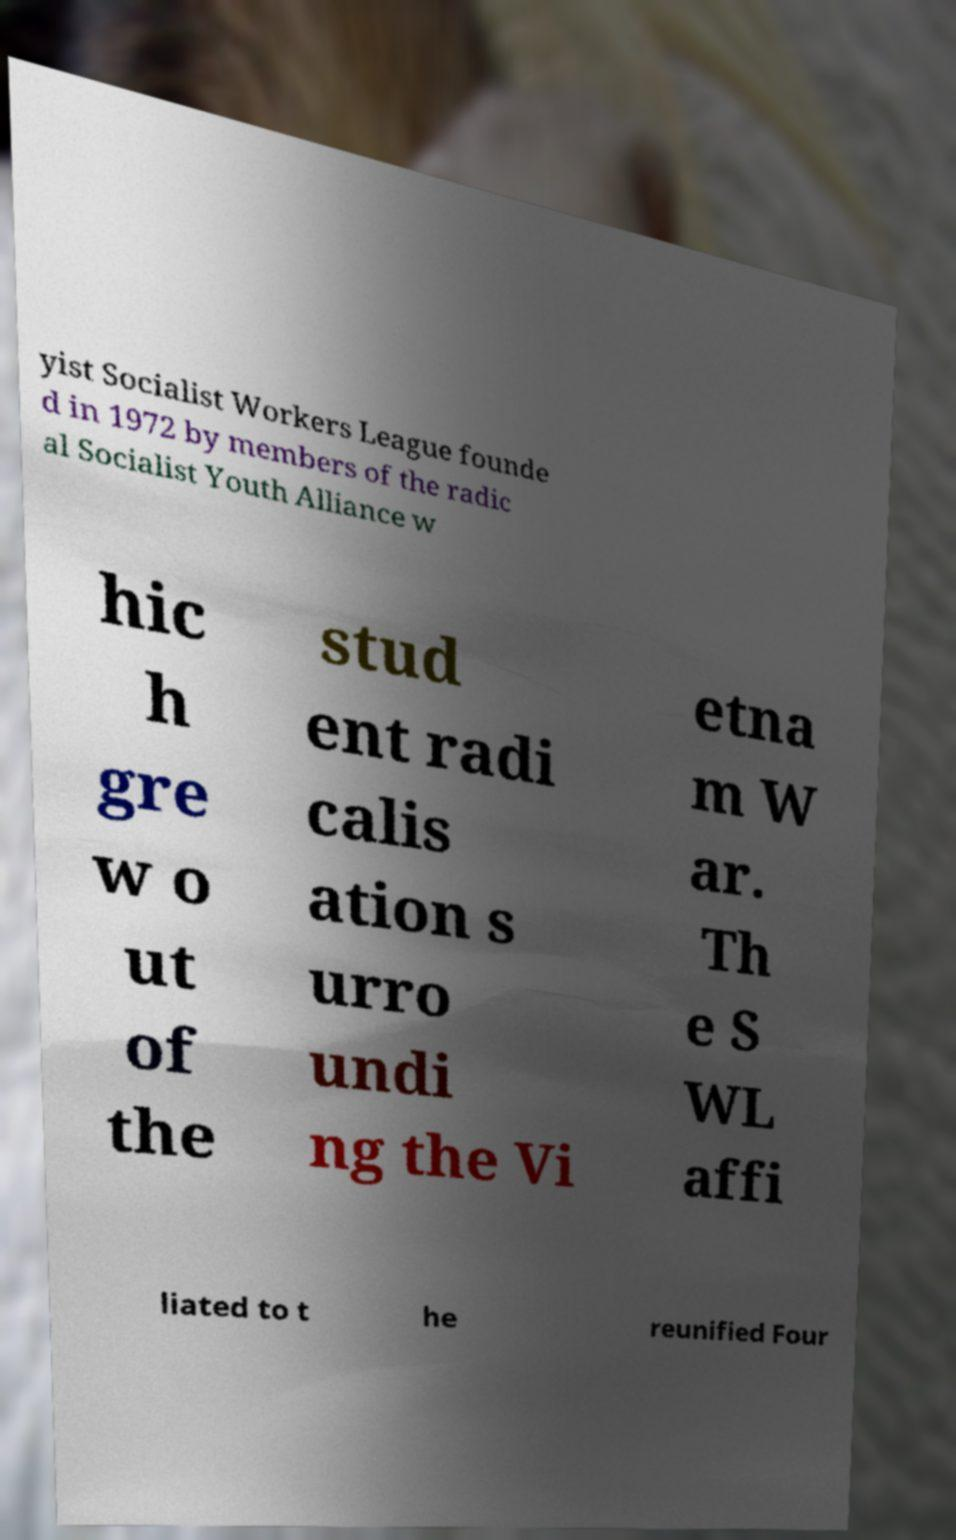Could you assist in decoding the text presented in this image and type it out clearly? yist Socialist Workers League founde d in 1972 by members of the radic al Socialist Youth Alliance w hic h gre w o ut of the stud ent radi calis ation s urro undi ng the Vi etna m W ar. Th e S WL affi liated to t he reunified Four 